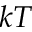Convert formula to latex. <formula><loc_0><loc_0><loc_500><loc_500>k T</formula> 